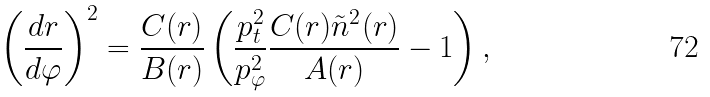<formula> <loc_0><loc_0><loc_500><loc_500>\left ( \frac { d r } { d \varphi } \right ) ^ { 2 } = \frac { C ( r ) } { B ( r ) } \left ( \frac { p _ { t } ^ { 2 } } { p _ { \varphi } ^ { 2 } } \frac { C ( r ) \tilde { n } ^ { 2 } ( r ) } { A ( r ) } - 1 \right ) ,</formula> 